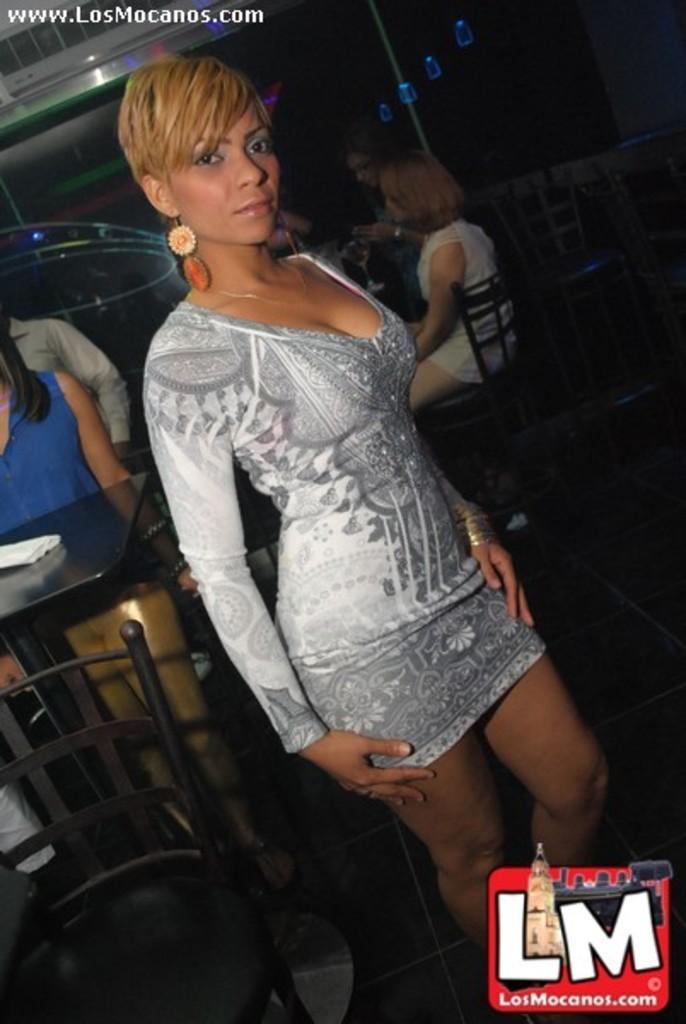In one or two sentences, can you explain what this image depicts? There is a girl in the center of the image there is a table and people those who are sitting on the chairs in the background area, it seems like stairs behind them. There is text at the top side. 